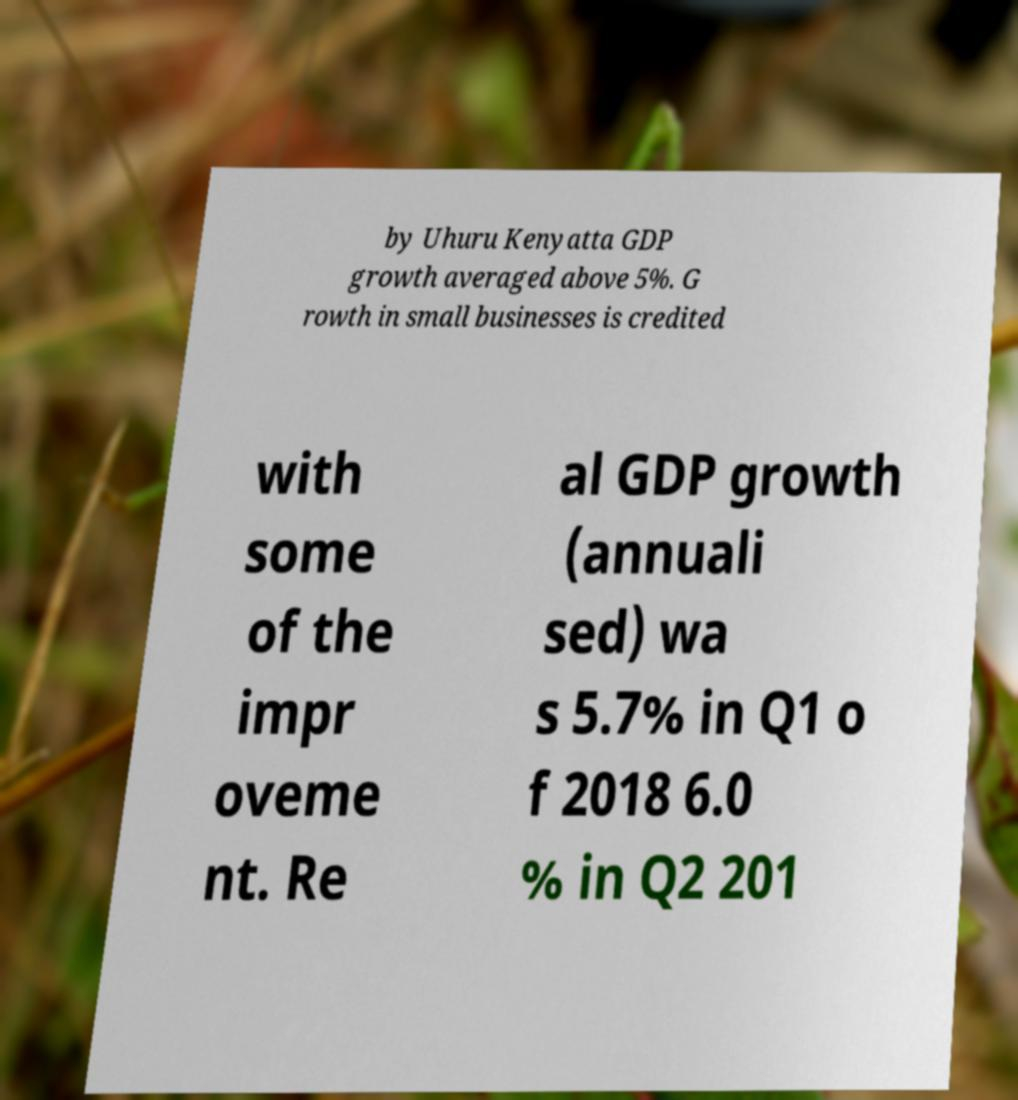Can you accurately transcribe the text from the provided image for me? by Uhuru Kenyatta GDP growth averaged above 5%. G rowth in small businesses is credited with some of the impr oveme nt. Re al GDP growth (annuali sed) wa s 5.7% in Q1 o f 2018 6.0 % in Q2 201 